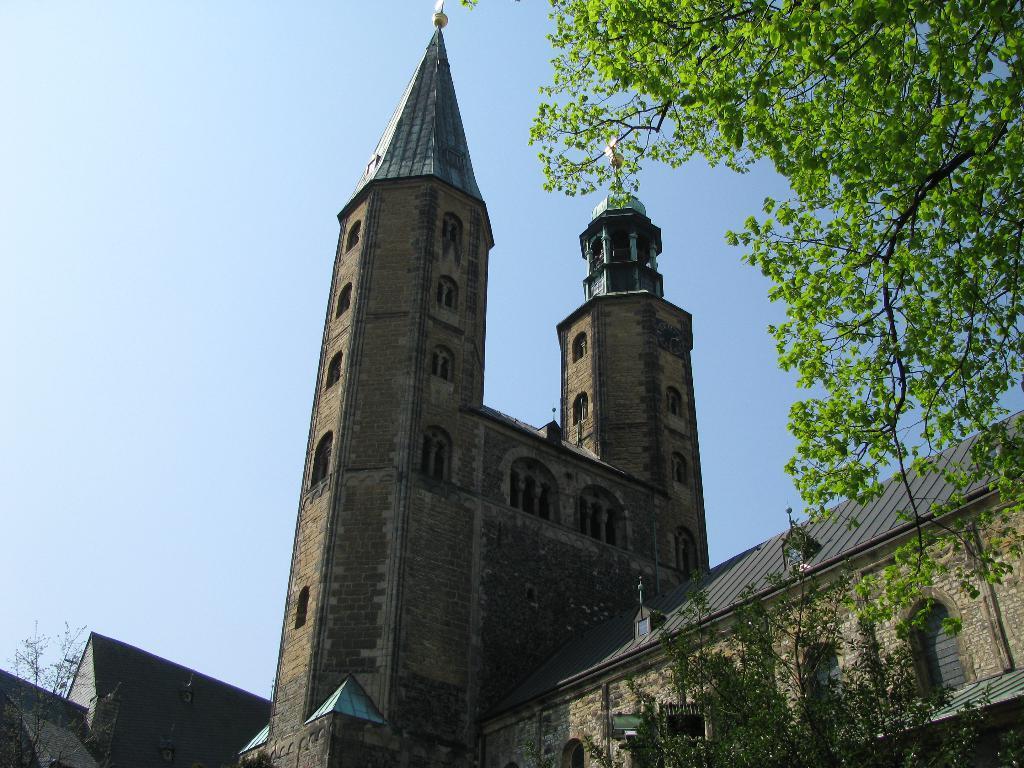Could you give a brief overview of what you see in this image? In this picture we can see few buildings and trees. 